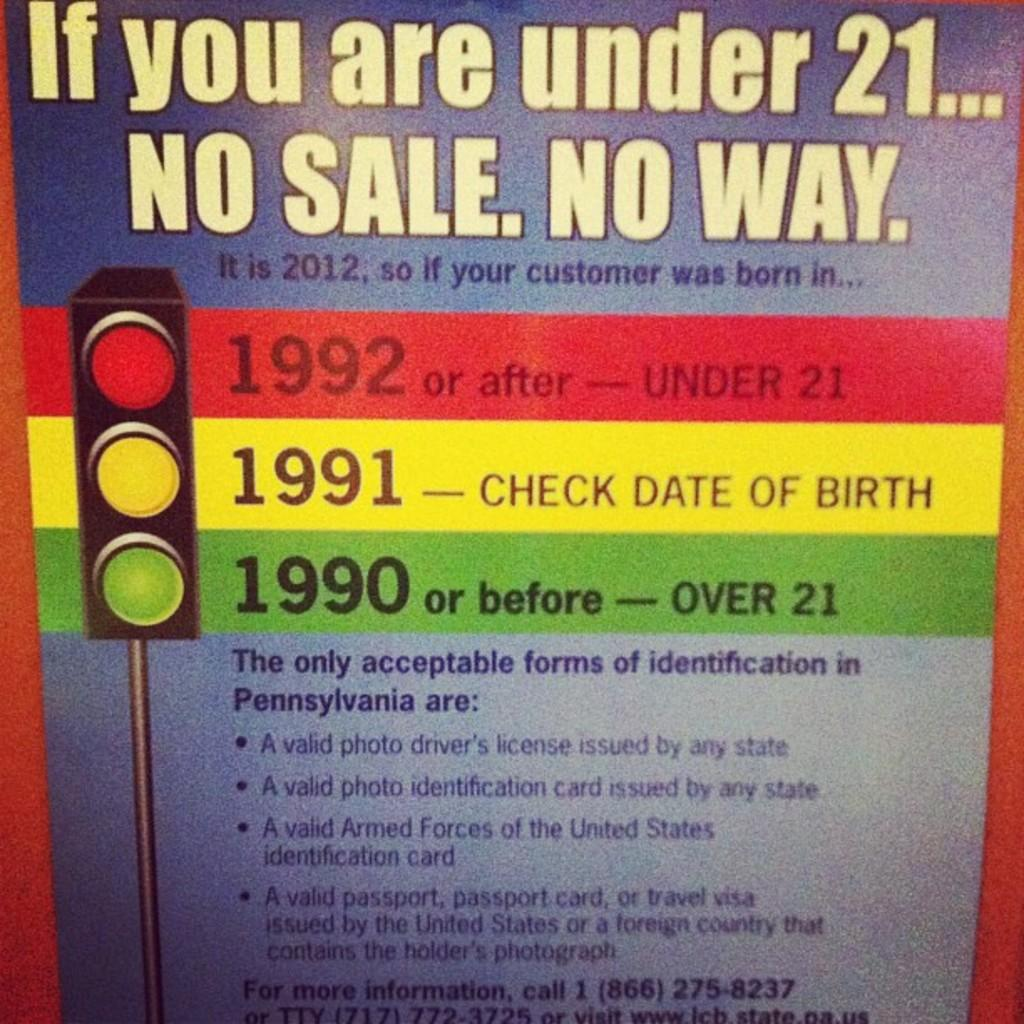<image>
Offer a succinct explanation of the picture presented. A poster showing indentification rules by birth date in the state of Pennsylvania. 